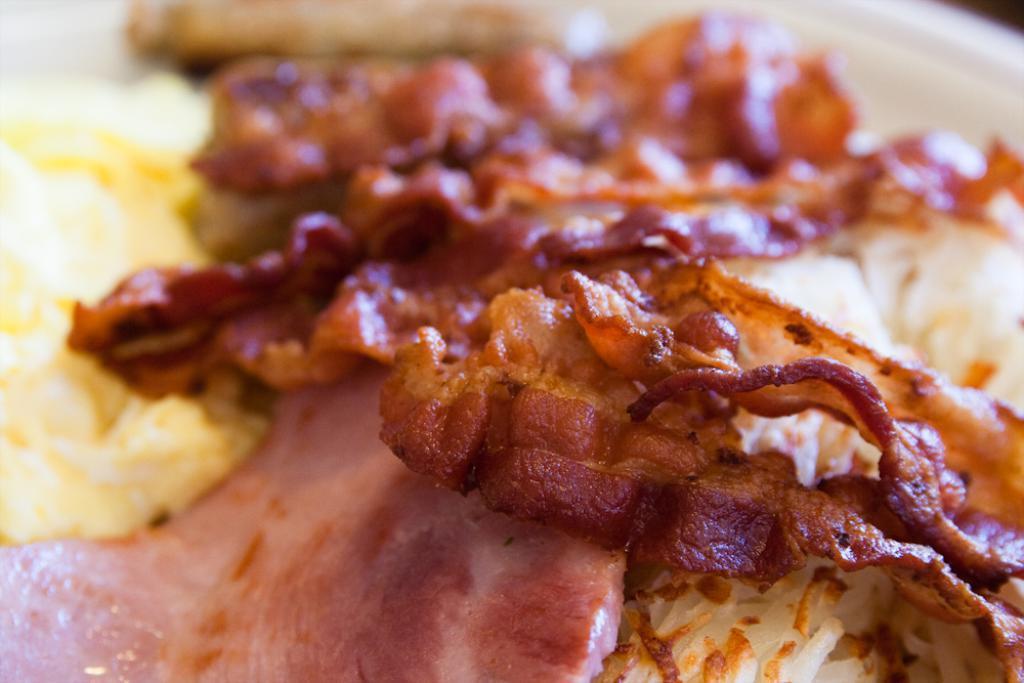Can you describe this image briefly? In this image I can see the food items. 